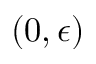Convert formula to latex. <formula><loc_0><loc_0><loc_500><loc_500>( 0 , \epsilon )</formula> 